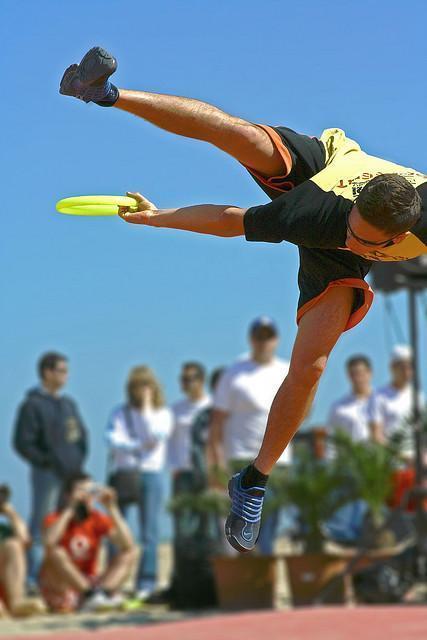How many people are in the photo?
Give a very brief answer. 10. 